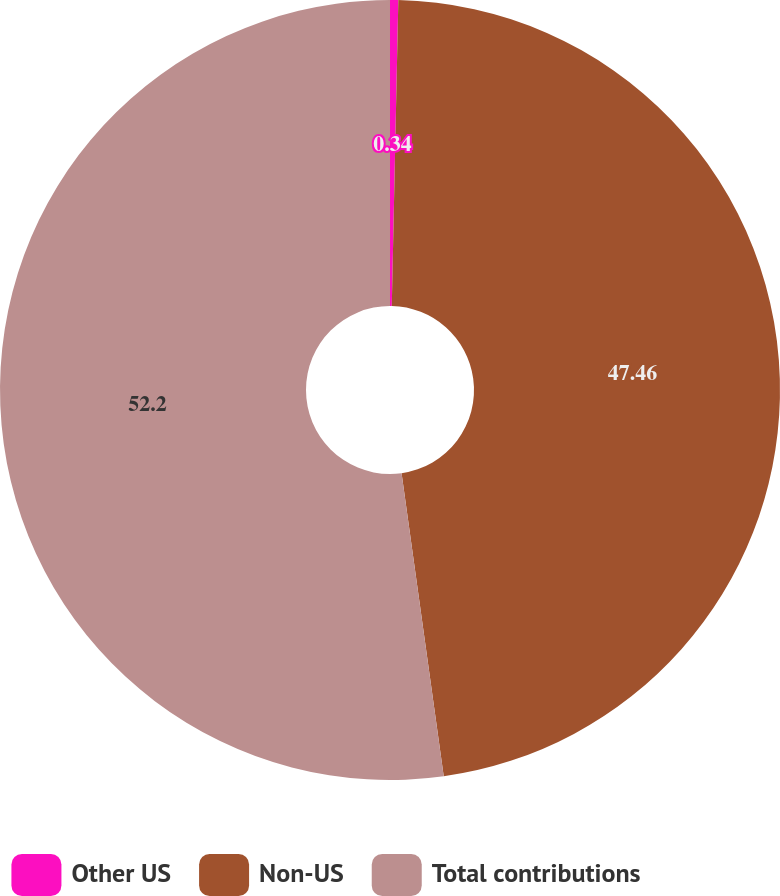Convert chart. <chart><loc_0><loc_0><loc_500><loc_500><pie_chart><fcel>Other US<fcel>Non-US<fcel>Total contributions<nl><fcel>0.34%<fcel>47.46%<fcel>52.2%<nl></chart> 